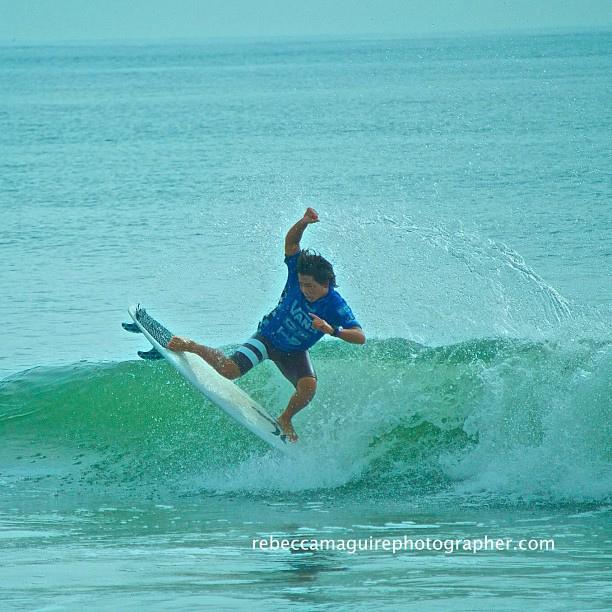Does the man's shirt have writing on it?
Answer briefly. Yes. Is this man falling?
Short answer required. No. What sport is this?
Be succinct. Surfing. 